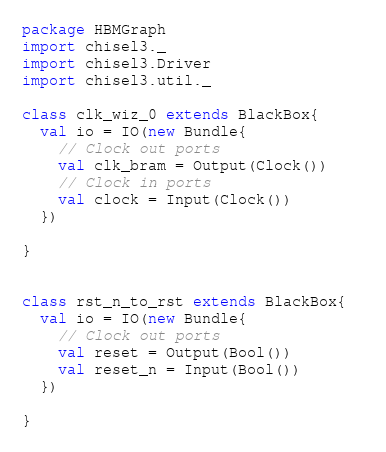<code> <loc_0><loc_0><loc_500><loc_500><_Scala_>package HBMGraph
import chisel3._
import chisel3.Driver
import chisel3.util._

class clk_wiz_0 extends BlackBox{  
  val io = IO(new Bundle{
    // Clock out ports
    val clk_bram = Output(Clock())
    // Clock in ports
    val clock = Input(Clock())
  })

}


class rst_n_to_rst extends BlackBox{  
  val io = IO(new Bundle{
    // Clock out ports
    val reset = Output(Bool())
    val reset_n = Input(Bool())
  })

}
</code> 